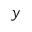<formula> <loc_0><loc_0><loc_500><loc_500>y</formula> 